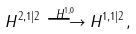Convert formula to latex. <formula><loc_0><loc_0><loc_500><loc_500>H ^ { 2 , 1 | 2 } \overset { H ^ { 1 , 0 } } \longrightarrow H ^ { 1 , 1 | 2 } ,</formula> 